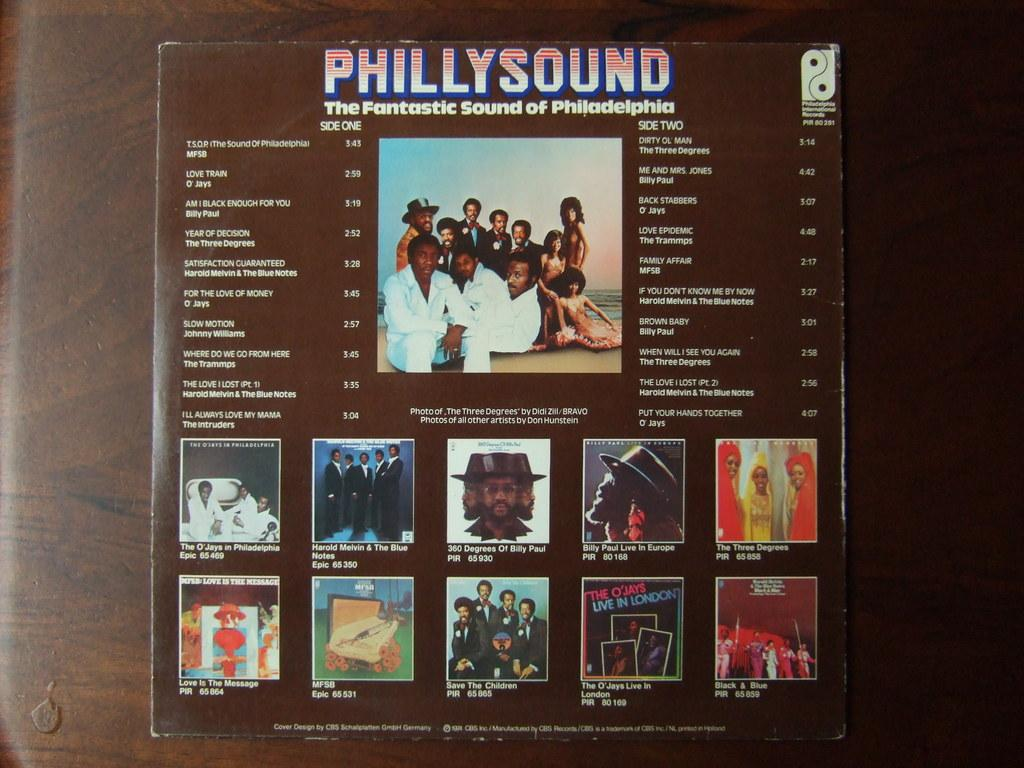What is present on the table in the image? There is a book on the table in the image. What can be found on the book? The book has text on it. Are there any people in the image? Yes, there are persons in the image. Can you see the moon in the image? No, the moon is not present in the image. Is there a harbor depicted in the image? No, there is no harbor in the image. 